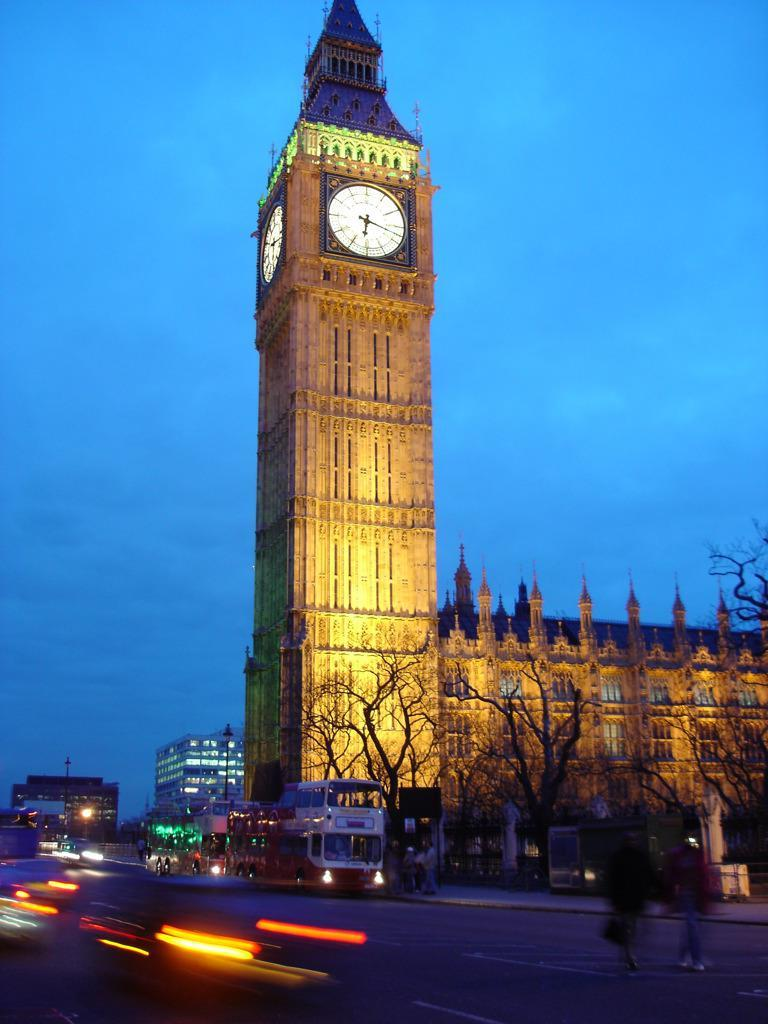What can be seen on the road in the image? There are vehicles and people on the road in the image. What type of vegetation is present in the image? There are dry trees in the image. What structures are visible in the image? There are buildings in the image, including one with a clock on the top. What year is the porter carrying in the image? There is no porter present in the image, and therefore no year can be associated with a porter. What is the friction between the vehicles and the road in the image? The image does not provide information about the friction between the vehicles and the road, as it is a still image and not a video. 